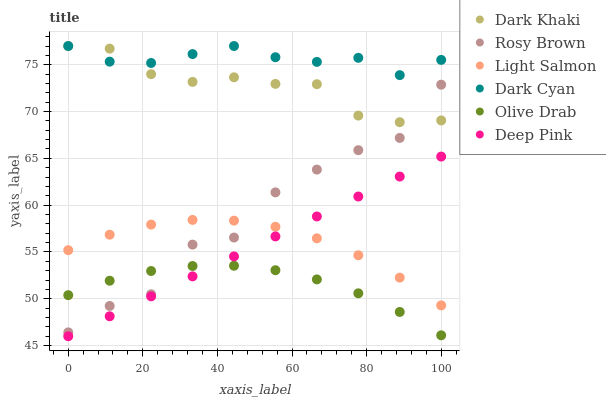Does Olive Drab have the minimum area under the curve?
Answer yes or no. Yes. Does Dark Cyan have the maximum area under the curve?
Answer yes or no. Yes. Does Deep Pink have the minimum area under the curve?
Answer yes or no. No. Does Deep Pink have the maximum area under the curve?
Answer yes or no. No. Is Deep Pink the smoothest?
Answer yes or no. Yes. Is Rosy Brown the roughest?
Answer yes or no. Yes. Is Rosy Brown the smoothest?
Answer yes or no. No. Is Deep Pink the roughest?
Answer yes or no. No. Does Deep Pink have the lowest value?
Answer yes or no. Yes. Does Rosy Brown have the lowest value?
Answer yes or no. No. Does Dark Cyan have the highest value?
Answer yes or no. Yes. Does Deep Pink have the highest value?
Answer yes or no. No. Is Light Salmon less than Dark Cyan?
Answer yes or no. Yes. Is Dark Cyan greater than Olive Drab?
Answer yes or no. Yes. Does Dark Cyan intersect Dark Khaki?
Answer yes or no. Yes. Is Dark Cyan less than Dark Khaki?
Answer yes or no. No. Is Dark Cyan greater than Dark Khaki?
Answer yes or no. No. Does Light Salmon intersect Dark Cyan?
Answer yes or no. No. 